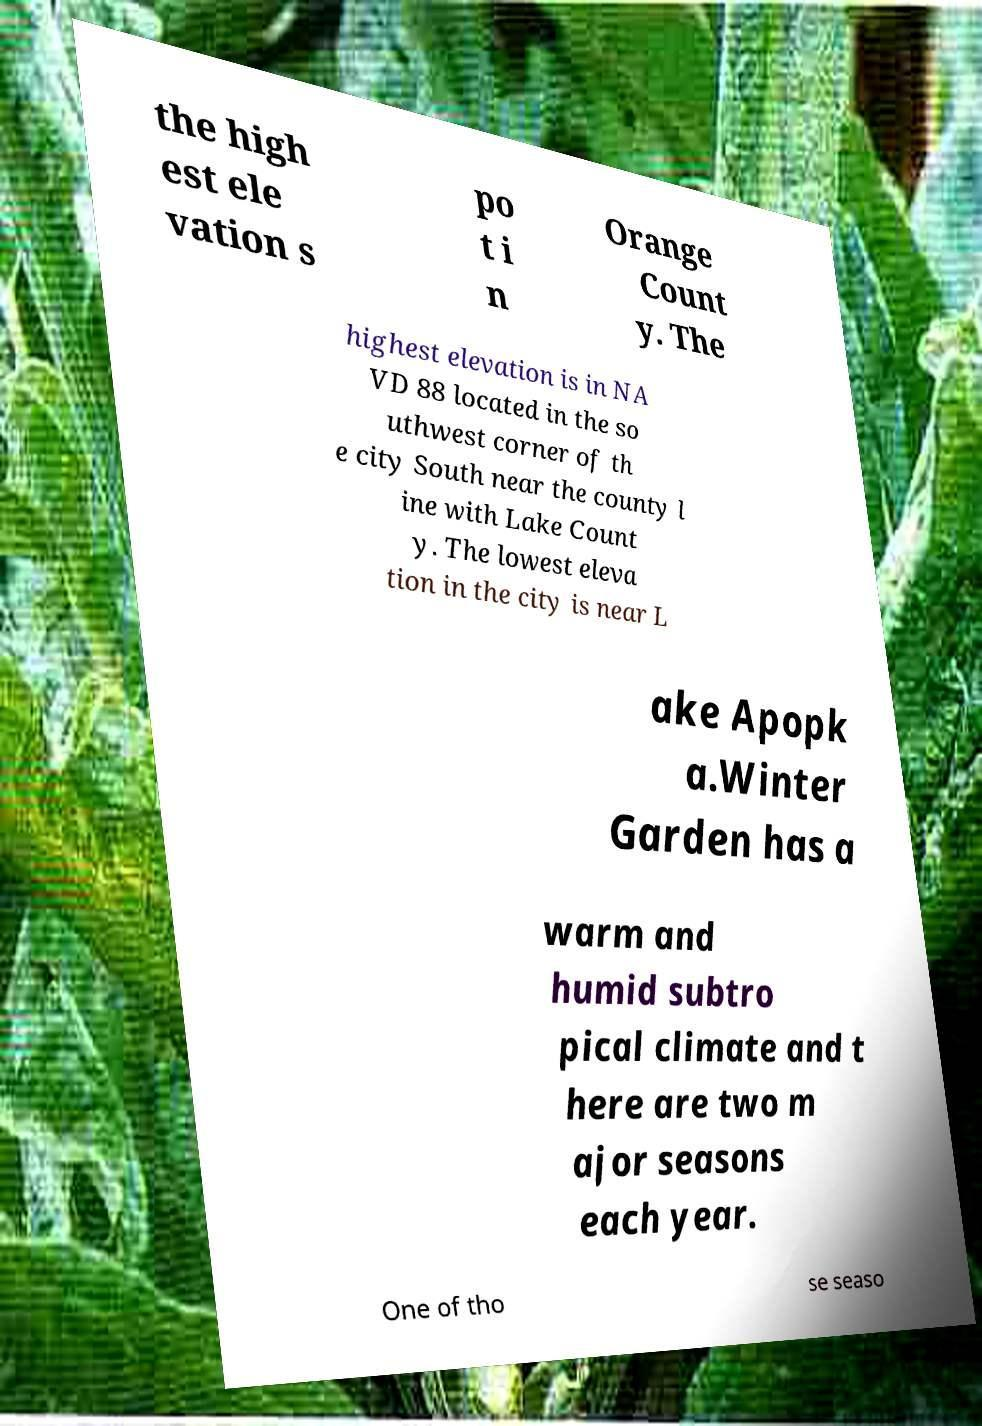I need the written content from this picture converted into text. Can you do that? the high est ele vation s po t i n Orange Count y. The highest elevation is in NA VD 88 located in the so uthwest corner of th e city South near the county l ine with Lake Count y. The lowest eleva tion in the city is near L ake Apopk a.Winter Garden has a warm and humid subtro pical climate and t here are two m ajor seasons each year. One of tho se seaso 